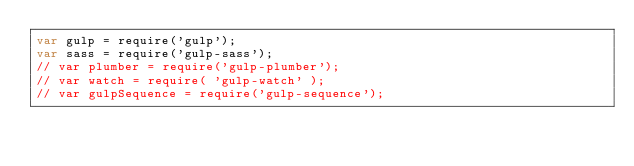<code> <loc_0><loc_0><loc_500><loc_500><_JavaScript_>var gulp = require('gulp');
var sass = require('gulp-sass');
// var plumber = require('gulp-plumber');
// var watch = require( 'gulp-watch' );
// var gulpSequence = require('gulp-sequence');</code> 